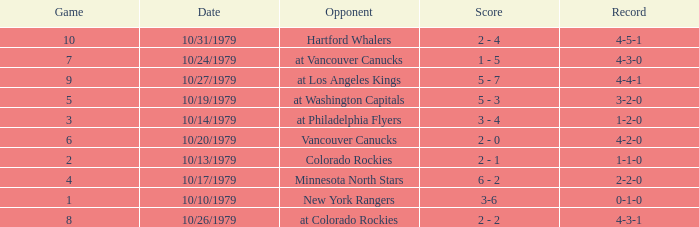Who is the opponent before game 5 with a 0-1-0 record? New York Rangers. 